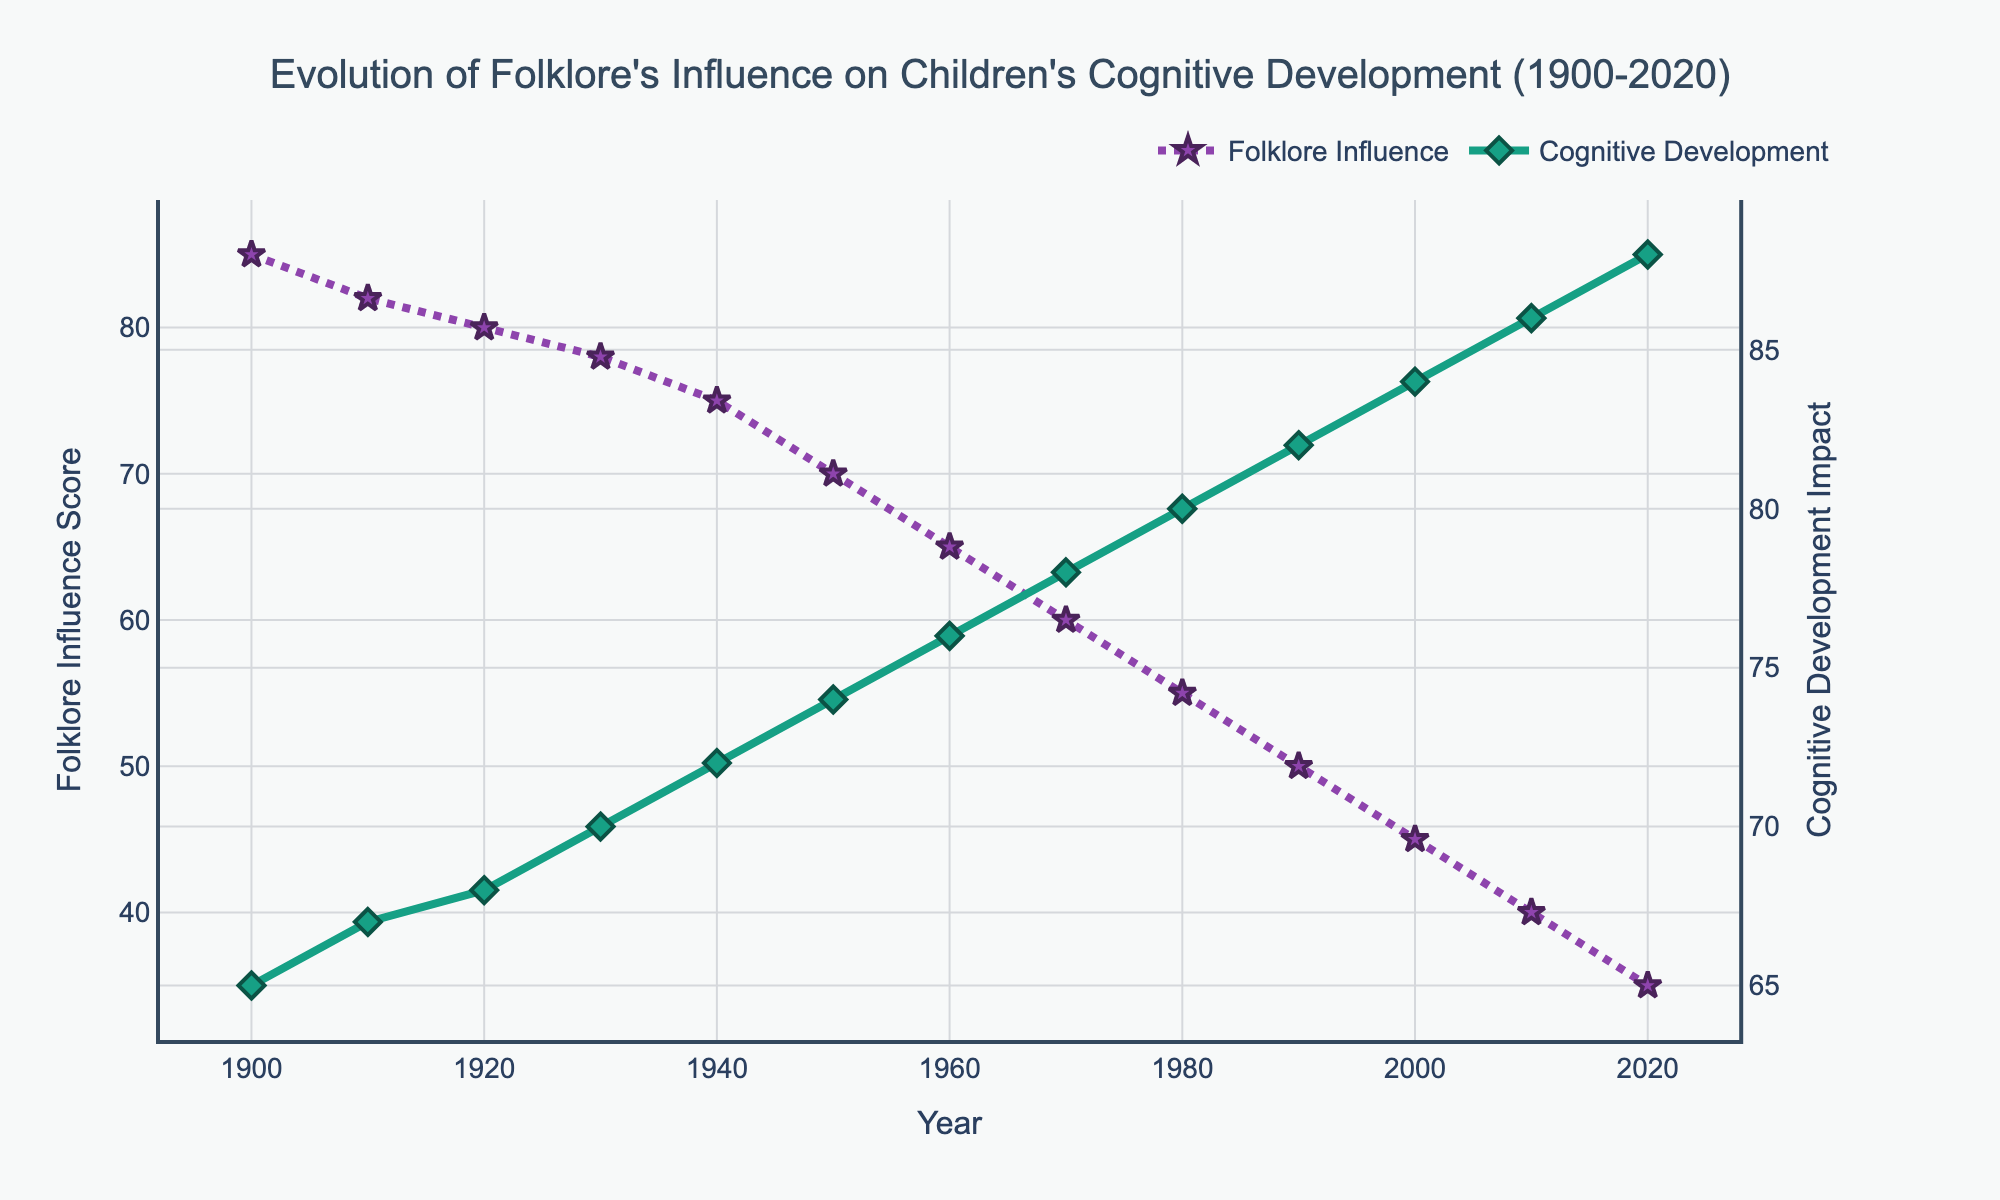What trend can be observed about folklore's influence score over the years? From the year 1900 to 2020, the folklore influence score shows a decreasing trend. Specifically, it drops from 85 in 1900 to 35 in 2020. By observing the line, we can see that the value consistently decreases over time.
Answer: Decreasing What year marks the point where the cognitive development impact overtakes the folklore influence score? By visually inspecting where the two lines intersect, we can see that the lines cross between 1960 and 1970. Thus, the intersection happens in the 1960s.
Answer: 1960s Which variable experienced a greater rate of change between 1900 and 2020? To determine the rate of change, compare the differences in the scores between these years. For folklore influence, the score decreases by 85 - 35 = 50 points. For cognitive development impact, the score increases by 88 - 65 = 23 points. Since the drop of 50 in folklore influence is larger than the increase of 23 in cognitive development impact, folklore influence experienced a greater rate of change.
Answer: Folklore influence How does the cognitive development impact in 2020 compare to that in 1900? By looking at the cognitive development scores for 1900 and 2020, we see that it was 65 in 1900 and increased to 88 in 2020. This indicates an increase over the years.
Answer: Increased What is the difference in folklore influence score between the years 1950 and 2000? From the plot, the folklore influence score in 1950 is 70 and in 2000 is 45. The difference is calculated as 70 - 45 = 25.
Answer: 25 Which line on the plot is represented by star markers, and what does it signify? The line with star markers is associated with folklore influence. This can be observed by noting the markers and matching their descriptions in the legend.
Answer: Folklore influence score Between which decades does the cognitive development impact increase most sharply? By inspecting the slope of the cognitive development line, the sharpest increase appears to be between 1900 and 1910 and from 2010 to 2020. Between these periods, the most significant visual increase occurs in the most recent decade from 2010 to 2020.
Answer: 2010-2020 